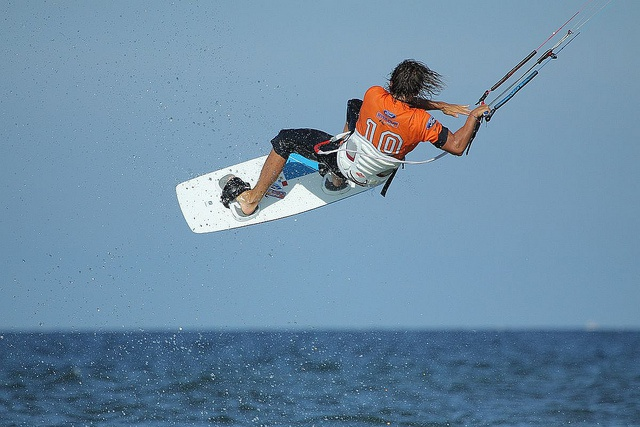Describe the objects in this image and their specific colors. I can see people in gray, black, red, and darkgray tones and surfboard in gray, white, and darkgray tones in this image. 